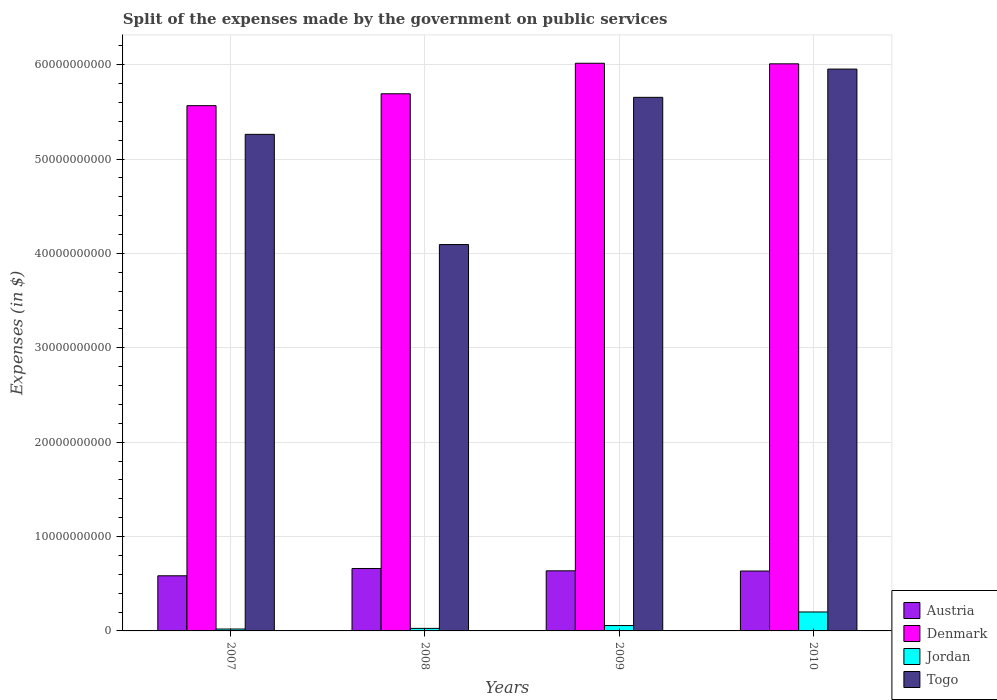How many different coloured bars are there?
Your answer should be very brief. 4. How many bars are there on the 4th tick from the left?
Provide a short and direct response. 4. How many bars are there on the 3rd tick from the right?
Keep it short and to the point. 4. What is the label of the 1st group of bars from the left?
Your response must be concise. 2007. What is the expenses made by the government on public services in Jordan in 2007?
Make the answer very short. 2.01e+08. Across all years, what is the maximum expenses made by the government on public services in Jordan?
Offer a very short reply. 2.01e+09. Across all years, what is the minimum expenses made by the government on public services in Austria?
Your answer should be compact. 5.84e+09. In which year was the expenses made by the government on public services in Jordan minimum?
Keep it short and to the point. 2007. What is the total expenses made by the government on public services in Jordan in the graph?
Offer a very short reply. 3.05e+09. What is the difference between the expenses made by the government on public services in Jordan in 2009 and that in 2010?
Your answer should be very brief. -1.44e+09. What is the difference between the expenses made by the government on public services in Togo in 2007 and the expenses made by the government on public services in Jordan in 2009?
Keep it short and to the point. 5.21e+1. What is the average expenses made by the government on public services in Denmark per year?
Keep it short and to the point. 5.82e+1. In the year 2007, what is the difference between the expenses made by the government on public services in Togo and expenses made by the government on public services in Jordan?
Your answer should be very brief. 5.24e+1. In how many years, is the expenses made by the government on public services in Togo greater than 22000000000 $?
Offer a very short reply. 4. What is the ratio of the expenses made by the government on public services in Denmark in 2008 to that in 2009?
Keep it short and to the point. 0.95. What is the difference between the highest and the second highest expenses made by the government on public services in Togo?
Keep it short and to the point. 2.99e+09. What is the difference between the highest and the lowest expenses made by the government on public services in Jordan?
Provide a succinct answer. 1.81e+09. Is the sum of the expenses made by the government on public services in Austria in 2007 and 2010 greater than the maximum expenses made by the government on public services in Jordan across all years?
Keep it short and to the point. Yes. What does the 2nd bar from the left in 2009 represents?
Your answer should be very brief. Denmark. What does the 1st bar from the right in 2007 represents?
Offer a terse response. Togo. Are all the bars in the graph horizontal?
Provide a succinct answer. No. What is the difference between two consecutive major ticks on the Y-axis?
Your answer should be compact. 1.00e+1. Are the values on the major ticks of Y-axis written in scientific E-notation?
Your answer should be very brief. No. Does the graph contain any zero values?
Provide a succinct answer. No. Does the graph contain grids?
Your answer should be compact. Yes. How many legend labels are there?
Make the answer very short. 4. What is the title of the graph?
Offer a terse response. Split of the expenses made by the government on public services. What is the label or title of the Y-axis?
Give a very brief answer. Expenses (in $). What is the Expenses (in $) in Austria in 2007?
Keep it short and to the point. 5.84e+09. What is the Expenses (in $) of Denmark in 2007?
Your answer should be compact. 5.57e+1. What is the Expenses (in $) in Jordan in 2007?
Your answer should be compact. 2.01e+08. What is the Expenses (in $) in Togo in 2007?
Make the answer very short. 5.26e+1. What is the Expenses (in $) in Austria in 2008?
Offer a terse response. 6.62e+09. What is the Expenses (in $) of Denmark in 2008?
Offer a terse response. 5.69e+1. What is the Expenses (in $) of Jordan in 2008?
Your answer should be very brief. 2.69e+08. What is the Expenses (in $) in Togo in 2008?
Provide a succinct answer. 4.09e+1. What is the Expenses (in $) in Austria in 2009?
Your answer should be compact. 6.37e+09. What is the Expenses (in $) in Denmark in 2009?
Give a very brief answer. 6.02e+1. What is the Expenses (in $) in Jordan in 2009?
Make the answer very short. 5.69e+08. What is the Expenses (in $) of Togo in 2009?
Keep it short and to the point. 5.65e+1. What is the Expenses (in $) of Austria in 2010?
Your answer should be very brief. 6.35e+09. What is the Expenses (in $) in Denmark in 2010?
Offer a very short reply. 6.01e+1. What is the Expenses (in $) in Jordan in 2010?
Ensure brevity in your answer.  2.01e+09. What is the Expenses (in $) of Togo in 2010?
Your answer should be compact. 5.95e+1. Across all years, what is the maximum Expenses (in $) of Austria?
Offer a terse response. 6.62e+09. Across all years, what is the maximum Expenses (in $) in Denmark?
Provide a short and direct response. 6.02e+1. Across all years, what is the maximum Expenses (in $) of Jordan?
Give a very brief answer. 2.01e+09. Across all years, what is the maximum Expenses (in $) in Togo?
Ensure brevity in your answer.  5.95e+1. Across all years, what is the minimum Expenses (in $) in Austria?
Give a very brief answer. 5.84e+09. Across all years, what is the minimum Expenses (in $) in Denmark?
Your response must be concise. 5.57e+1. Across all years, what is the minimum Expenses (in $) in Jordan?
Give a very brief answer. 2.01e+08. Across all years, what is the minimum Expenses (in $) in Togo?
Offer a terse response. 4.09e+1. What is the total Expenses (in $) in Austria in the graph?
Provide a short and direct response. 2.52e+1. What is the total Expenses (in $) of Denmark in the graph?
Ensure brevity in your answer.  2.33e+11. What is the total Expenses (in $) of Jordan in the graph?
Ensure brevity in your answer.  3.05e+09. What is the total Expenses (in $) of Togo in the graph?
Your answer should be compact. 2.10e+11. What is the difference between the Expenses (in $) in Austria in 2007 and that in 2008?
Offer a very short reply. -7.74e+08. What is the difference between the Expenses (in $) of Denmark in 2007 and that in 2008?
Make the answer very short. -1.26e+09. What is the difference between the Expenses (in $) in Jordan in 2007 and that in 2008?
Offer a very short reply. -6.76e+07. What is the difference between the Expenses (in $) in Togo in 2007 and that in 2008?
Your response must be concise. 1.17e+1. What is the difference between the Expenses (in $) in Austria in 2007 and that in 2009?
Keep it short and to the point. -5.26e+08. What is the difference between the Expenses (in $) of Denmark in 2007 and that in 2009?
Ensure brevity in your answer.  -4.49e+09. What is the difference between the Expenses (in $) in Jordan in 2007 and that in 2009?
Make the answer very short. -3.68e+08. What is the difference between the Expenses (in $) in Togo in 2007 and that in 2009?
Your response must be concise. -3.92e+09. What is the difference between the Expenses (in $) of Austria in 2007 and that in 2010?
Provide a short and direct response. -5.04e+08. What is the difference between the Expenses (in $) in Denmark in 2007 and that in 2010?
Your response must be concise. -4.43e+09. What is the difference between the Expenses (in $) in Jordan in 2007 and that in 2010?
Make the answer very short. -1.81e+09. What is the difference between the Expenses (in $) in Togo in 2007 and that in 2010?
Provide a succinct answer. -6.92e+09. What is the difference between the Expenses (in $) in Austria in 2008 and that in 2009?
Give a very brief answer. 2.48e+08. What is the difference between the Expenses (in $) of Denmark in 2008 and that in 2009?
Make the answer very short. -3.23e+09. What is the difference between the Expenses (in $) in Jordan in 2008 and that in 2009?
Offer a terse response. -3.00e+08. What is the difference between the Expenses (in $) in Togo in 2008 and that in 2009?
Provide a succinct answer. -1.56e+1. What is the difference between the Expenses (in $) in Austria in 2008 and that in 2010?
Ensure brevity in your answer.  2.69e+08. What is the difference between the Expenses (in $) of Denmark in 2008 and that in 2010?
Keep it short and to the point. -3.17e+09. What is the difference between the Expenses (in $) of Jordan in 2008 and that in 2010?
Keep it short and to the point. -1.74e+09. What is the difference between the Expenses (in $) of Togo in 2008 and that in 2010?
Ensure brevity in your answer.  -1.86e+1. What is the difference between the Expenses (in $) in Austria in 2009 and that in 2010?
Your response must be concise. 2.17e+07. What is the difference between the Expenses (in $) of Denmark in 2009 and that in 2010?
Offer a very short reply. 6.10e+07. What is the difference between the Expenses (in $) of Jordan in 2009 and that in 2010?
Provide a succinct answer. -1.44e+09. What is the difference between the Expenses (in $) of Togo in 2009 and that in 2010?
Provide a succinct answer. -2.99e+09. What is the difference between the Expenses (in $) in Austria in 2007 and the Expenses (in $) in Denmark in 2008?
Your response must be concise. -5.11e+1. What is the difference between the Expenses (in $) of Austria in 2007 and the Expenses (in $) of Jordan in 2008?
Provide a short and direct response. 5.57e+09. What is the difference between the Expenses (in $) in Austria in 2007 and the Expenses (in $) in Togo in 2008?
Make the answer very short. -3.51e+1. What is the difference between the Expenses (in $) in Denmark in 2007 and the Expenses (in $) in Jordan in 2008?
Make the answer very short. 5.54e+1. What is the difference between the Expenses (in $) in Denmark in 2007 and the Expenses (in $) in Togo in 2008?
Make the answer very short. 1.47e+1. What is the difference between the Expenses (in $) of Jordan in 2007 and the Expenses (in $) of Togo in 2008?
Make the answer very short. -4.07e+1. What is the difference between the Expenses (in $) in Austria in 2007 and the Expenses (in $) in Denmark in 2009?
Keep it short and to the point. -5.43e+1. What is the difference between the Expenses (in $) in Austria in 2007 and the Expenses (in $) in Jordan in 2009?
Make the answer very short. 5.27e+09. What is the difference between the Expenses (in $) in Austria in 2007 and the Expenses (in $) in Togo in 2009?
Give a very brief answer. -5.07e+1. What is the difference between the Expenses (in $) in Denmark in 2007 and the Expenses (in $) in Jordan in 2009?
Ensure brevity in your answer.  5.51e+1. What is the difference between the Expenses (in $) in Denmark in 2007 and the Expenses (in $) in Togo in 2009?
Your answer should be compact. -8.81e+08. What is the difference between the Expenses (in $) of Jordan in 2007 and the Expenses (in $) of Togo in 2009?
Give a very brief answer. -5.63e+1. What is the difference between the Expenses (in $) of Austria in 2007 and the Expenses (in $) of Denmark in 2010?
Make the answer very short. -5.43e+1. What is the difference between the Expenses (in $) of Austria in 2007 and the Expenses (in $) of Jordan in 2010?
Ensure brevity in your answer.  3.83e+09. What is the difference between the Expenses (in $) of Austria in 2007 and the Expenses (in $) of Togo in 2010?
Your answer should be compact. -5.37e+1. What is the difference between the Expenses (in $) in Denmark in 2007 and the Expenses (in $) in Jordan in 2010?
Your answer should be very brief. 5.37e+1. What is the difference between the Expenses (in $) of Denmark in 2007 and the Expenses (in $) of Togo in 2010?
Offer a very short reply. -3.87e+09. What is the difference between the Expenses (in $) in Jordan in 2007 and the Expenses (in $) in Togo in 2010?
Offer a very short reply. -5.93e+1. What is the difference between the Expenses (in $) in Austria in 2008 and the Expenses (in $) in Denmark in 2009?
Your response must be concise. -5.35e+1. What is the difference between the Expenses (in $) in Austria in 2008 and the Expenses (in $) in Jordan in 2009?
Offer a very short reply. 6.05e+09. What is the difference between the Expenses (in $) in Austria in 2008 and the Expenses (in $) in Togo in 2009?
Offer a very short reply. -4.99e+1. What is the difference between the Expenses (in $) of Denmark in 2008 and the Expenses (in $) of Jordan in 2009?
Your response must be concise. 5.64e+1. What is the difference between the Expenses (in $) of Denmark in 2008 and the Expenses (in $) of Togo in 2009?
Your response must be concise. 3.78e+08. What is the difference between the Expenses (in $) of Jordan in 2008 and the Expenses (in $) of Togo in 2009?
Keep it short and to the point. -5.63e+1. What is the difference between the Expenses (in $) in Austria in 2008 and the Expenses (in $) in Denmark in 2010?
Keep it short and to the point. -5.35e+1. What is the difference between the Expenses (in $) in Austria in 2008 and the Expenses (in $) in Jordan in 2010?
Your response must be concise. 4.61e+09. What is the difference between the Expenses (in $) in Austria in 2008 and the Expenses (in $) in Togo in 2010?
Provide a succinct answer. -5.29e+1. What is the difference between the Expenses (in $) of Denmark in 2008 and the Expenses (in $) of Jordan in 2010?
Make the answer very short. 5.49e+1. What is the difference between the Expenses (in $) in Denmark in 2008 and the Expenses (in $) in Togo in 2010?
Your answer should be very brief. -2.62e+09. What is the difference between the Expenses (in $) of Jordan in 2008 and the Expenses (in $) of Togo in 2010?
Ensure brevity in your answer.  -5.93e+1. What is the difference between the Expenses (in $) in Austria in 2009 and the Expenses (in $) in Denmark in 2010?
Your response must be concise. -5.37e+1. What is the difference between the Expenses (in $) in Austria in 2009 and the Expenses (in $) in Jordan in 2010?
Provide a succinct answer. 4.36e+09. What is the difference between the Expenses (in $) of Austria in 2009 and the Expenses (in $) of Togo in 2010?
Offer a very short reply. -5.32e+1. What is the difference between the Expenses (in $) of Denmark in 2009 and the Expenses (in $) of Jordan in 2010?
Provide a short and direct response. 5.81e+1. What is the difference between the Expenses (in $) of Denmark in 2009 and the Expenses (in $) of Togo in 2010?
Make the answer very short. 6.18e+08. What is the difference between the Expenses (in $) of Jordan in 2009 and the Expenses (in $) of Togo in 2010?
Your response must be concise. -5.90e+1. What is the average Expenses (in $) in Austria per year?
Your response must be concise. 6.29e+09. What is the average Expenses (in $) of Denmark per year?
Keep it short and to the point. 5.82e+1. What is the average Expenses (in $) in Jordan per year?
Your answer should be compact. 7.62e+08. What is the average Expenses (in $) in Togo per year?
Offer a terse response. 5.24e+1. In the year 2007, what is the difference between the Expenses (in $) of Austria and Expenses (in $) of Denmark?
Give a very brief answer. -4.98e+1. In the year 2007, what is the difference between the Expenses (in $) in Austria and Expenses (in $) in Jordan?
Make the answer very short. 5.64e+09. In the year 2007, what is the difference between the Expenses (in $) in Austria and Expenses (in $) in Togo?
Your response must be concise. -4.68e+1. In the year 2007, what is the difference between the Expenses (in $) in Denmark and Expenses (in $) in Jordan?
Your response must be concise. 5.55e+1. In the year 2007, what is the difference between the Expenses (in $) in Denmark and Expenses (in $) in Togo?
Your answer should be very brief. 3.04e+09. In the year 2007, what is the difference between the Expenses (in $) of Jordan and Expenses (in $) of Togo?
Your response must be concise. -5.24e+1. In the year 2008, what is the difference between the Expenses (in $) in Austria and Expenses (in $) in Denmark?
Your response must be concise. -5.03e+1. In the year 2008, what is the difference between the Expenses (in $) of Austria and Expenses (in $) of Jordan?
Give a very brief answer. 6.35e+09. In the year 2008, what is the difference between the Expenses (in $) of Austria and Expenses (in $) of Togo?
Your answer should be very brief. -3.43e+1. In the year 2008, what is the difference between the Expenses (in $) in Denmark and Expenses (in $) in Jordan?
Your answer should be very brief. 5.67e+1. In the year 2008, what is the difference between the Expenses (in $) in Denmark and Expenses (in $) in Togo?
Offer a very short reply. 1.60e+1. In the year 2008, what is the difference between the Expenses (in $) in Jordan and Expenses (in $) in Togo?
Offer a terse response. -4.07e+1. In the year 2009, what is the difference between the Expenses (in $) in Austria and Expenses (in $) in Denmark?
Keep it short and to the point. -5.38e+1. In the year 2009, what is the difference between the Expenses (in $) of Austria and Expenses (in $) of Jordan?
Provide a succinct answer. 5.80e+09. In the year 2009, what is the difference between the Expenses (in $) of Austria and Expenses (in $) of Togo?
Give a very brief answer. -5.02e+1. In the year 2009, what is the difference between the Expenses (in $) in Denmark and Expenses (in $) in Jordan?
Ensure brevity in your answer.  5.96e+1. In the year 2009, what is the difference between the Expenses (in $) in Denmark and Expenses (in $) in Togo?
Your answer should be very brief. 3.61e+09. In the year 2009, what is the difference between the Expenses (in $) of Jordan and Expenses (in $) of Togo?
Provide a short and direct response. -5.60e+1. In the year 2010, what is the difference between the Expenses (in $) of Austria and Expenses (in $) of Denmark?
Offer a very short reply. -5.37e+1. In the year 2010, what is the difference between the Expenses (in $) of Austria and Expenses (in $) of Jordan?
Provide a succinct answer. 4.34e+09. In the year 2010, what is the difference between the Expenses (in $) of Austria and Expenses (in $) of Togo?
Provide a short and direct response. -5.32e+1. In the year 2010, what is the difference between the Expenses (in $) of Denmark and Expenses (in $) of Jordan?
Offer a very short reply. 5.81e+1. In the year 2010, what is the difference between the Expenses (in $) of Denmark and Expenses (in $) of Togo?
Your answer should be compact. 5.57e+08. In the year 2010, what is the difference between the Expenses (in $) of Jordan and Expenses (in $) of Togo?
Provide a succinct answer. -5.75e+1. What is the ratio of the Expenses (in $) in Austria in 2007 to that in 2008?
Make the answer very short. 0.88. What is the ratio of the Expenses (in $) in Denmark in 2007 to that in 2008?
Offer a very short reply. 0.98. What is the ratio of the Expenses (in $) of Jordan in 2007 to that in 2008?
Offer a very short reply. 0.75. What is the ratio of the Expenses (in $) of Togo in 2007 to that in 2008?
Your answer should be compact. 1.29. What is the ratio of the Expenses (in $) of Austria in 2007 to that in 2009?
Offer a very short reply. 0.92. What is the ratio of the Expenses (in $) of Denmark in 2007 to that in 2009?
Make the answer very short. 0.93. What is the ratio of the Expenses (in $) in Jordan in 2007 to that in 2009?
Offer a terse response. 0.35. What is the ratio of the Expenses (in $) in Togo in 2007 to that in 2009?
Your answer should be compact. 0.93. What is the ratio of the Expenses (in $) in Austria in 2007 to that in 2010?
Offer a terse response. 0.92. What is the ratio of the Expenses (in $) in Denmark in 2007 to that in 2010?
Your answer should be compact. 0.93. What is the ratio of the Expenses (in $) in Jordan in 2007 to that in 2010?
Offer a very short reply. 0.1. What is the ratio of the Expenses (in $) of Togo in 2007 to that in 2010?
Keep it short and to the point. 0.88. What is the ratio of the Expenses (in $) in Austria in 2008 to that in 2009?
Ensure brevity in your answer.  1.04. What is the ratio of the Expenses (in $) of Denmark in 2008 to that in 2009?
Provide a short and direct response. 0.95. What is the ratio of the Expenses (in $) of Jordan in 2008 to that in 2009?
Offer a very short reply. 0.47. What is the ratio of the Expenses (in $) of Togo in 2008 to that in 2009?
Provide a succinct answer. 0.72. What is the ratio of the Expenses (in $) in Austria in 2008 to that in 2010?
Offer a very short reply. 1.04. What is the ratio of the Expenses (in $) in Denmark in 2008 to that in 2010?
Your response must be concise. 0.95. What is the ratio of the Expenses (in $) of Jordan in 2008 to that in 2010?
Offer a very short reply. 0.13. What is the ratio of the Expenses (in $) of Togo in 2008 to that in 2010?
Give a very brief answer. 0.69. What is the ratio of the Expenses (in $) of Austria in 2009 to that in 2010?
Ensure brevity in your answer.  1. What is the ratio of the Expenses (in $) of Jordan in 2009 to that in 2010?
Give a very brief answer. 0.28. What is the ratio of the Expenses (in $) of Togo in 2009 to that in 2010?
Offer a very short reply. 0.95. What is the difference between the highest and the second highest Expenses (in $) of Austria?
Make the answer very short. 2.48e+08. What is the difference between the highest and the second highest Expenses (in $) in Denmark?
Provide a succinct answer. 6.10e+07. What is the difference between the highest and the second highest Expenses (in $) in Jordan?
Keep it short and to the point. 1.44e+09. What is the difference between the highest and the second highest Expenses (in $) in Togo?
Your response must be concise. 2.99e+09. What is the difference between the highest and the lowest Expenses (in $) of Austria?
Make the answer very short. 7.74e+08. What is the difference between the highest and the lowest Expenses (in $) in Denmark?
Your answer should be compact. 4.49e+09. What is the difference between the highest and the lowest Expenses (in $) of Jordan?
Give a very brief answer. 1.81e+09. What is the difference between the highest and the lowest Expenses (in $) in Togo?
Give a very brief answer. 1.86e+1. 